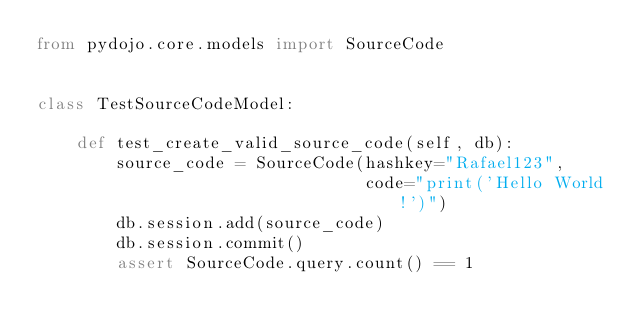Convert code to text. <code><loc_0><loc_0><loc_500><loc_500><_Python_>from pydojo.core.models import SourceCode


class TestSourceCodeModel:

    def test_create_valid_source_code(self, db):
        source_code = SourceCode(hashkey="Rafael123",
                                 code="print('Hello World!')")
        db.session.add(source_code)
        db.session.commit()
        assert SourceCode.query.count() == 1
</code> 